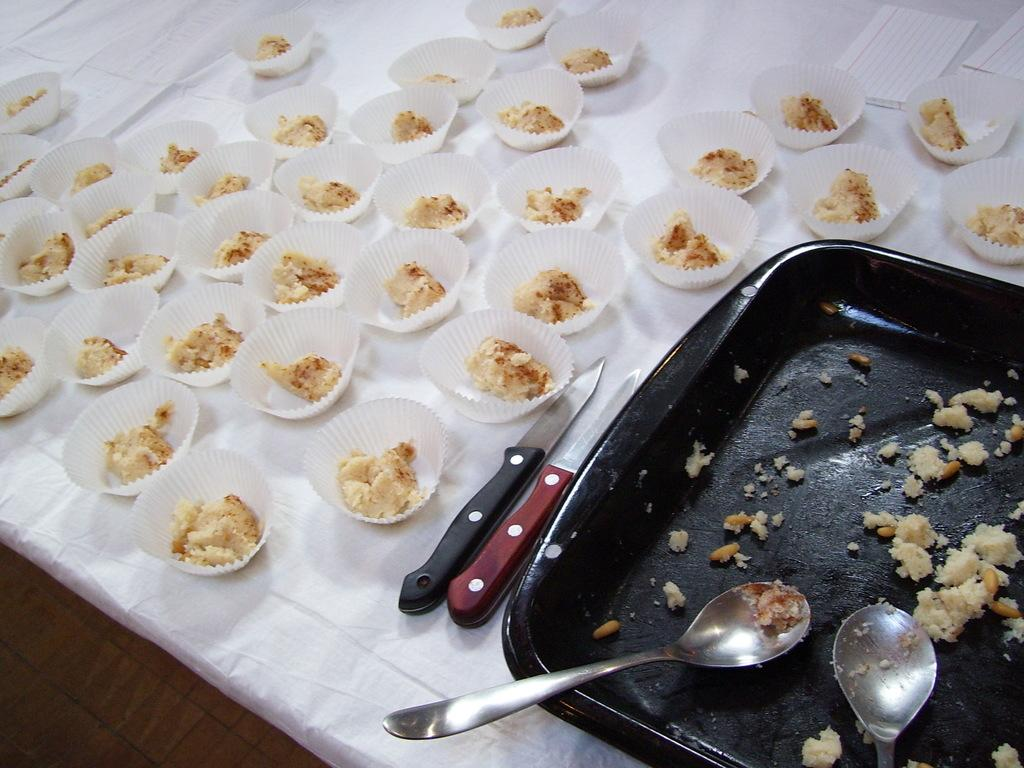What object is present in the image that can hold multiple items? There is a tray in the image. What items are on the tray? The tray contains spoons, knives, and tissue papers. What type of food is in the cups in the image? The cups contain food, but the specific type of food is not mentioned. Where are the cups placed in the image? The cups are placed on a table. What type of coal can be seen on the shelf in the image? There is no coal or shelf present in the image. What type of trousers are being worn by the person in the image? There is no person or trousers mentioned in the given facts. 